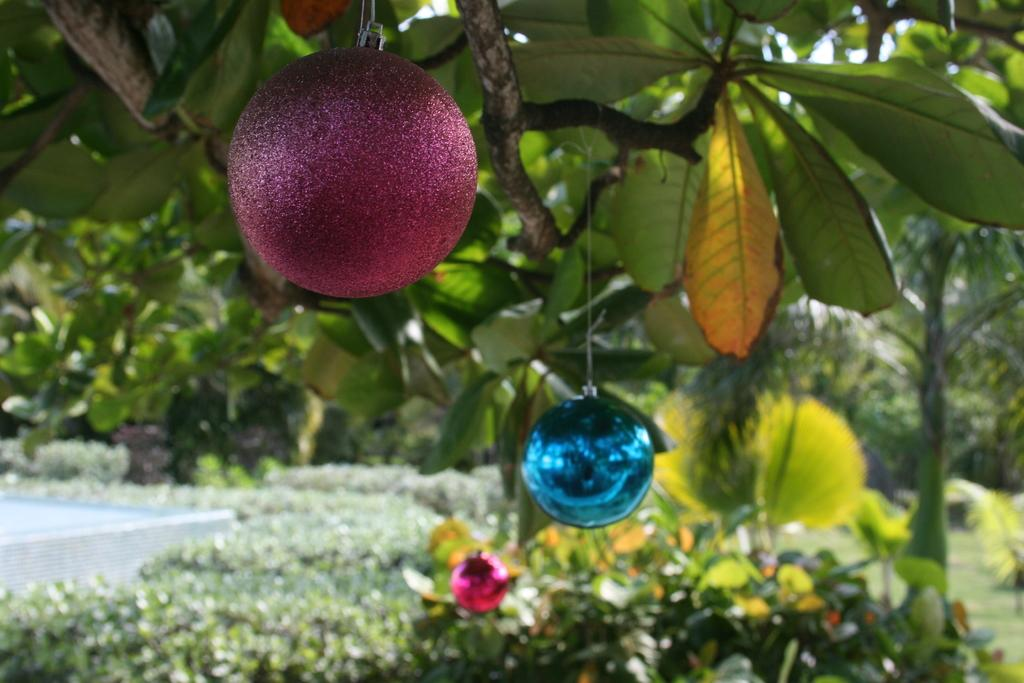What type of natural elements can be seen in the image? There are trees in the image. What type of man-made objects can be seen in the image? There are decorative objects in the image. What type of vegetation can be seen at the bottom of the image? There are plants at the bottom of the image. What type of steel frame is visible in the image? There is no steel frame present in the image. What fact can be determined about the plants at the bottom of the image? The fact that there are plants at the bottom of the image is already mentioned in the conversation, so there is no additional fact to determine. 